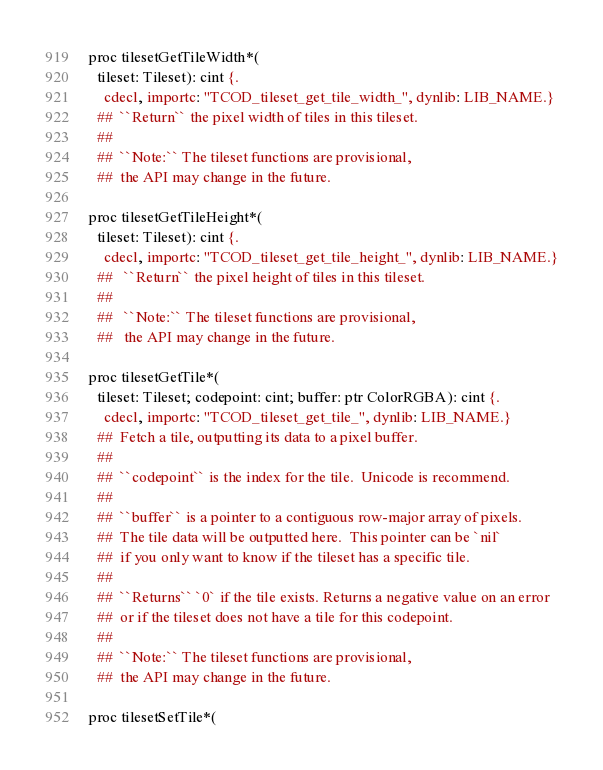<code> <loc_0><loc_0><loc_500><loc_500><_Nim_>proc tilesetGetTileWidth*(
  tileset: Tileset): cint {.
    cdecl, importc: "TCOD_tileset_get_tile_width_", dynlib: LIB_NAME.}
  ##  ``Return`` the pixel width of tiles in this tileset.
  ##
  ##  ``Note:`` The tileset functions are provisional,
  ##  the API may change in the future.

proc tilesetGetTileHeight*(
  tileset: Tileset): cint {.
    cdecl, importc: "TCOD_tileset_get_tile_height_", dynlib: LIB_NAME.}
  ##   ``Return`` the pixel height of tiles in this tileset.
  ##
  ##   ``Note:`` The tileset functions are provisional,
  ##   the API may change in the future.

proc tilesetGetTile*(
  tileset: Tileset; codepoint: cint; buffer: ptr ColorRGBA): cint {.
    cdecl, importc: "TCOD_tileset_get_tile_", dynlib: LIB_NAME.}
  ##  Fetch a tile, outputting its data to a pixel buffer.
  ##
  ##  ``codepoint`` is the index for the tile.  Unicode is recommend.
  ##
  ##  ``buffer`` is a pointer to a contiguous row-major array of pixels.
  ##  The tile data will be outputted here.  This pointer can be `nil`
  ##  if you only want to know if the tileset has a specific tile.
  ##
  ##  ``Returns`` `0` if the tile exists. Returns a negative value on an error
  ##  or if the tileset does not have a tile for this codepoint.
  ##
  ##  ``Note:`` The tileset functions are provisional,
  ##  the API may change in the future.

proc tilesetSetTile*(</code> 